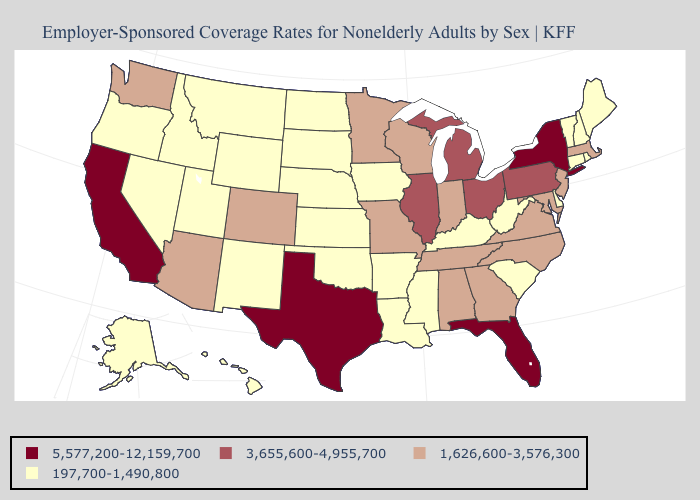Which states hav the highest value in the West?
Be succinct. California. Among the states that border Virginia , does West Virginia have the highest value?
Give a very brief answer. No. Among the states that border Vermont , which have the highest value?
Write a very short answer. New York. What is the value of Pennsylvania?
Short answer required. 3,655,600-4,955,700. What is the lowest value in the USA?
Concise answer only. 197,700-1,490,800. Which states have the highest value in the USA?
Keep it brief. California, Florida, New York, Texas. What is the value of Wisconsin?
Write a very short answer. 1,626,600-3,576,300. Name the states that have a value in the range 197,700-1,490,800?
Concise answer only. Alaska, Arkansas, Connecticut, Delaware, Hawaii, Idaho, Iowa, Kansas, Kentucky, Louisiana, Maine, Mississippi, Montana, Nebraska, Nevada, New Hampshire, New Mexico, North Dakota, Oklahoma, Oregon, Rhode Island, South Carolina, South Dakota, Utah, Vermont, West Virginia, Wyoming. Among the states that border North Carolina , does South Carolina have the highest value?
Give a very brief answer. No. Name the states that have a value in the range 5,577,200-12,159,700?
Short answer required. California, Florida, New York, Texas. Does New Hampshire have the highest value in the Northeast?
Keep it brief. No. Does Iowa have a lower value than Tennessee?
Write a very short answer. Yes. Does Arizona have the same value as New Jersey?
Answer briefly. Yes. Among the states that border North Dakota , does South Dakota have the lowest value?
Write a very short answer. Yes. What is the value of South Dakota?
Keep it brief. 197,700-1,490,800. 